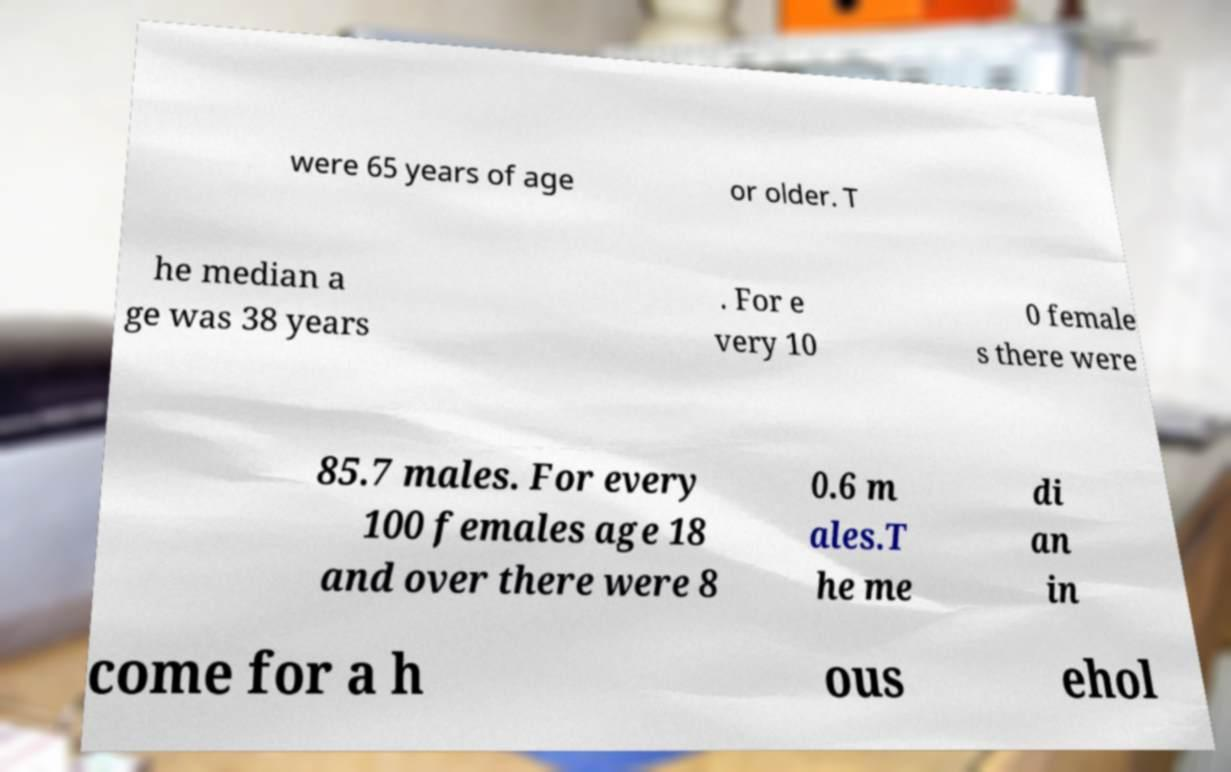Could you extract and type out the text from this image? were 65 years of age or older. T he median a ge was 38 years . For e very 10 0 female s there were 85.7 males. For every 100 females age 18 and over there were 8 0.6 m ales.T he me di an in come for a h ous ehol 